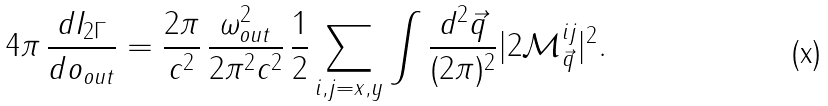Convert formula to latex. <formula><loc_0><loc_0><loc_500><loc_500>4 \pi \, \frac { d I _ { 2 \Gamma } } { d o _ { o u t } } = \frac { 2 \pi } { c ^ { 2 } } \, \frac { \omega _ { o u t } ^ { 2 } } { 2 \pi ^ { 2 } c ^ { 2 } } \, \frac { 1 } { 2 } \sum _ { i , j = x , y } \int \frac { d ^ { 2 } \vec { q } } { ( 2 \pi ) ^ { 2 } } | 2 \mathcal { M } ^ { i j } _ { \vec { q } } | ^ { 2 } .</formula> 